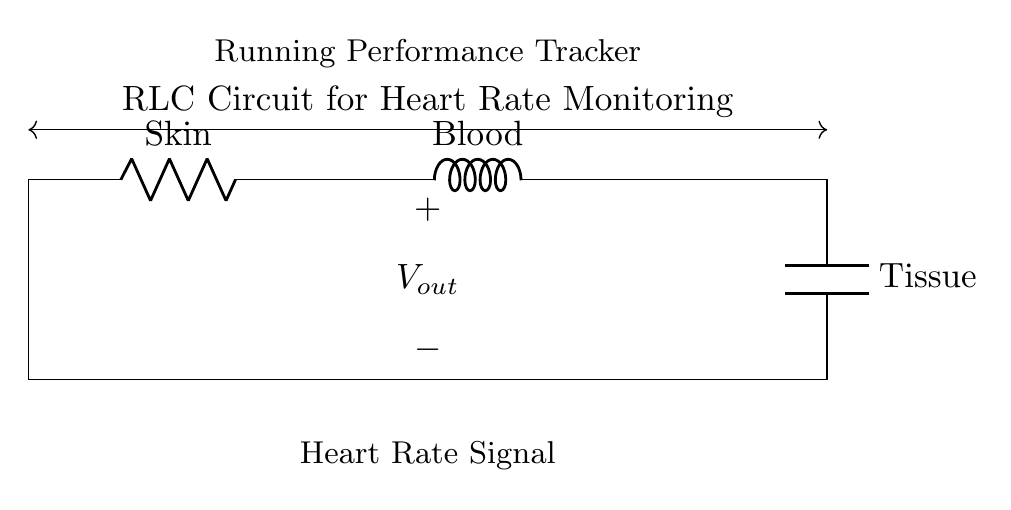What component represents the skin in the circuit? The component indicating the skin in the circuit is labeled as "R_s," which denotes it as a resistor, signifying the resistance of the skin.
Answer: R_s What is the role of the inductor in this circuit? The inductor labeled "L_b" in the circuit represents the blood. It plays a role in storing energy in the form of a magnetic field and can affect the current flow, which can be relevant in sensing heart rate fluctuations.
Answer: L_b What is the output of this RLC circuit? The output of the circuit is denoted by "V_out," which gives the heart rate signal, indicating the voltage signal that is measured to analyze heart rate.
Answer: V_out Which component is used to model the tissue? The component used to model the tissue in the circuit is the capacitor labeled "C_t," which represents the ability of tissue to store electrical charge, important for understanding the heart's electrical activity.
Answer: C_t How does the arrangement of R, L, and C affect the circuit's response? The arrangement of the resistor R_s, inductor L_b, and capacitor C_t in series affects the impedance of the circuit, influencing how the circuit responds to varying frequencies, such as those of heartbeats, allowing for effective monitoring of heart rates.
Answer: Affects impedance What is the significance of the heart rate signal labeled in the diagram? The heart rate signal labeled under "V_out" is significant because it allows for the monitoring of heart activity, vital for assessing physical performance and health during running workouts.
Answer: Monitoring heart activity What can be inferred about the circuit type given its components and configuration? This circuit is an RLC circuit composed of a resistor, inductor, and capacitor in series, which collectively enables resonant behavior and filtering characteristics, ideal for processing signals like heart rates during exercise.
Answer: RLC circuit 